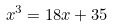<formula> <loc_0><loc_0><loc_500><loc_500>x ^ { 3 } = 1 8 x + 3 5</formula> 